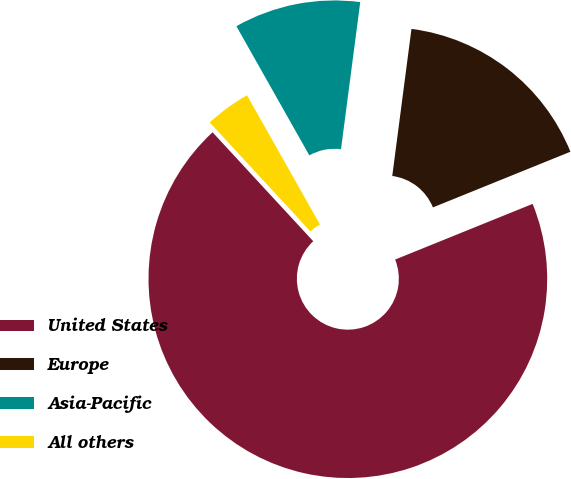Convert chart to OTSL. <chart><loc_0><loc_0><loc_500><loc_500><pie_chart><fcel>United States<fcel>Europe<fcel>Asia-Pacific<fcel>All others<nl><fcel>69.25%<fcel>16.81%<fcel>10.25%<fcel>3.69%<nl></chart> 